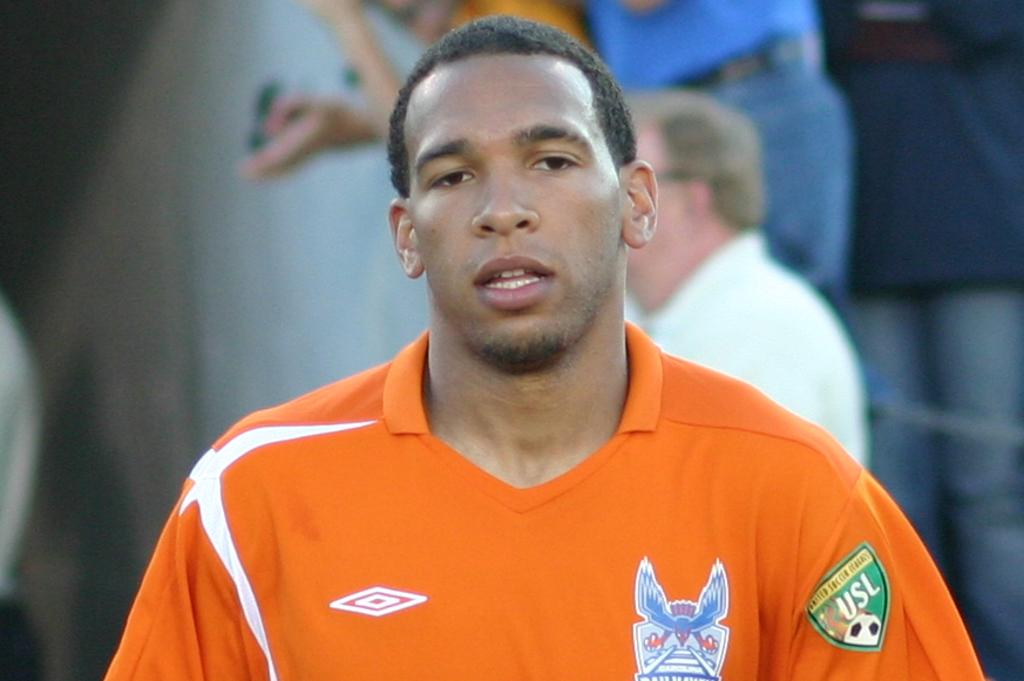<image>
Write a terse but informative summary of the picture. a man in an orange jersey with USL on the sleeve 